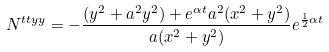<formula> <loc_0><loc_0><loc_500><loc_500>N ^ { t t y y } = - \frac { ( y ^ { 2 } + a ^ { 2 } y ^ { 2 } ) + e ^ { \alpha t } a ^ { 2 } ( x ^ { 2 } + y ^ { 2 } ) } { a ( x ^ { 2 } + y ^ { 2 } ) } e ^ { \frac { 1 } { 2 } \alpha t }</formula> 